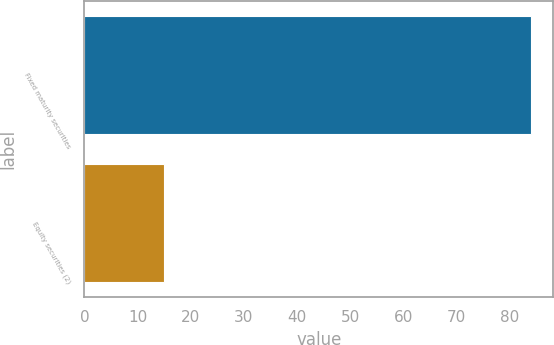Convert chart. <chart><loc_0><loc_0><loc_500><loc_500><bar_chart><fcel>Fixed maturity securities<fcel>Equity securities (2)<nl><fcel>84<fcel>15<nl></chart> 